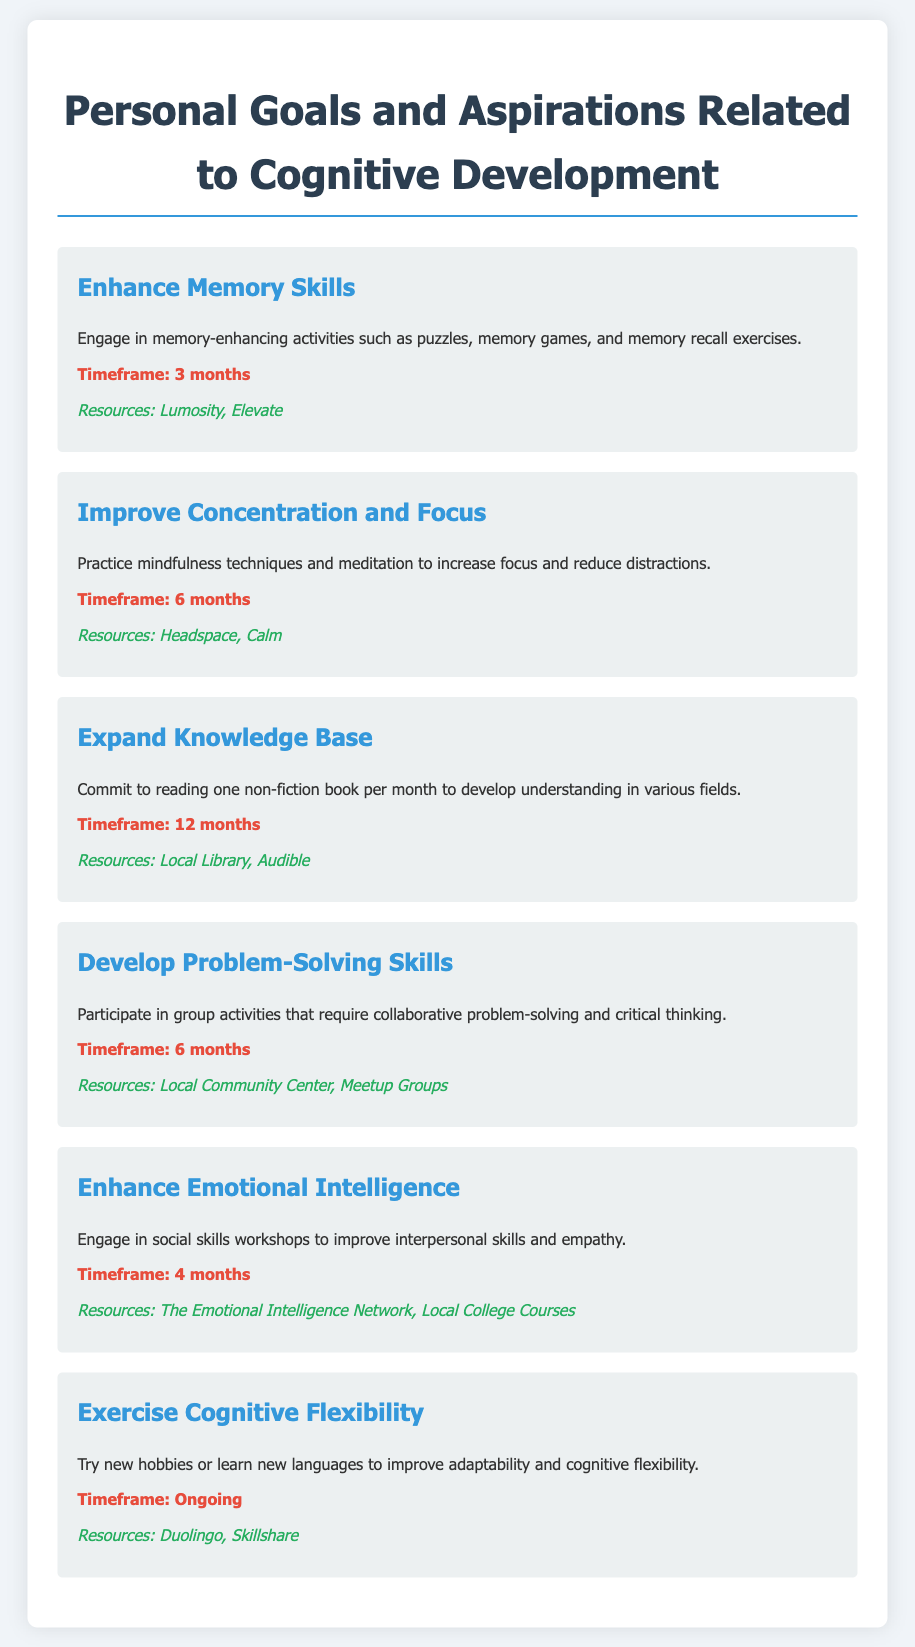What is the first goal listed? The first goal in the document is "Enhance Memory Skills."
Answer: Enhance Memory Skills What is the timeframe for improving concentration and focus? The timeframe specified for this goal is 6 months.
Answer: 6 months Which resources are suggested for enhancing emotional intelligence? The document lists "The Emotional Intelligence Network" and "Local College Courses" as resources.
Answer: The Emotional Intelligence Network, Local College Courses How many months is the timeframe for expanding the knowledge base? The timeframe provided for this goal is 12 months.
Answer: 12 months What is one activity suggested to enhance memory skills? The document suggests engaging in memory-enhancing activities such as puzzles.
Answer: puzzles Which goal focuses on social skills? The goal that focuses on social skills is "Enhance Emotional Intelligence."
Answer: Enhance Emotional Intelligence What is the timeframe for exercising cognitive flexibility? The document states that exercising cognitive flexibility is ongoing.
Answer: Ongoing List one resource for improving problem-solving skills. One resource suggested for this goal is "Local Community Center."
Answer: Local Community Center 